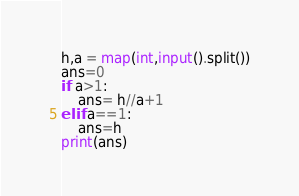<code> <loc_0><loc_0><loc_500><loc_500><_Python_>h,a = map(int,input().split())
ans=0
if a>1:
    ans= h//a+1
elif a==1:
    ans=h
print(ans)</code> 